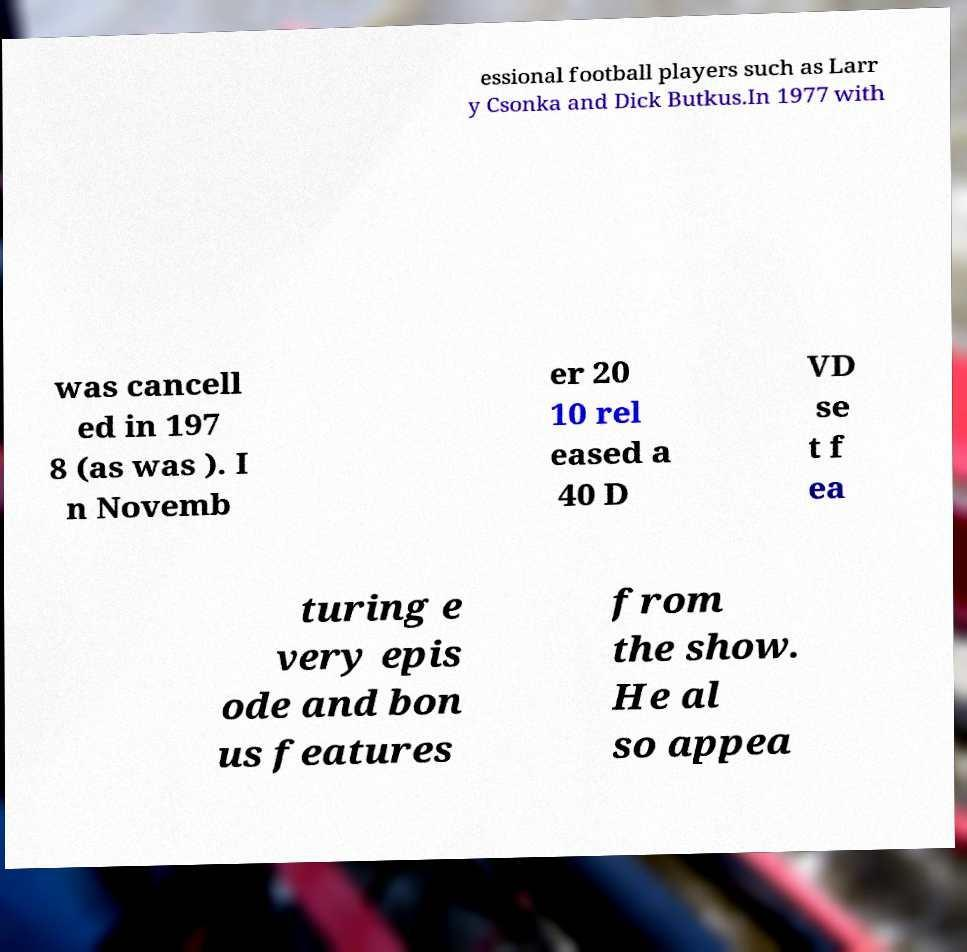Can you read and provide the text displayed in the image?This photo seems to have some interesting text. Can you extract and type it out for me? essional football players such as Larr y Csonka and Dick Butkus.In 1977 with was cancell ed in 197 8 (as was ). I n Novemb er 20 10 rel eased a 40 D VD se t f ea turing e very epis ode and bon us features from the show. He al so appea 